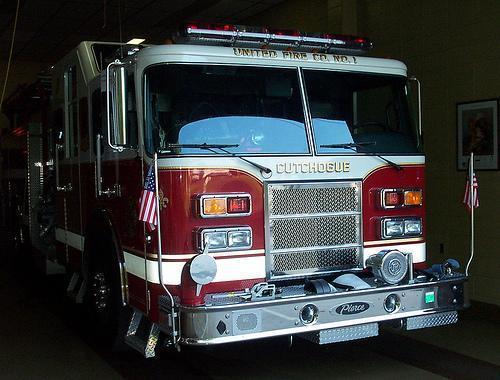How many trucks are shown?
Give a very brief answer. 1. How many windshields are on the truck?
Give a very brief answer. 2. 